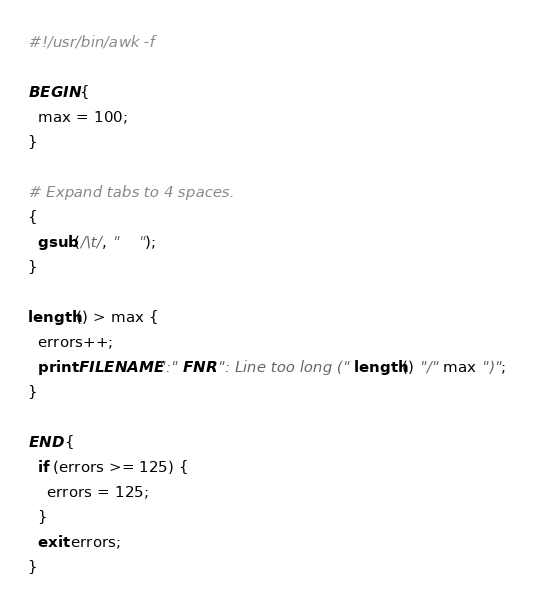Convert code to text. <code><loc_0><loc_0><loc_500><loc_500><_Awk_>#!/usr/bin/awk -f

BEGIN {
  max = 100;
}

# Expand tabs to 4 spaces.
{
  gsub(/\t/, "    ");
}

length() > max {
  errors++;
  print FILENAME ":" FNR ": Line too long (" length() "/" max ")";
}

END {
  if (errors >= 125) {
    errors = 125;
  }
  exit errors;
}
</code> 